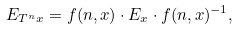Convert formula to latex. <formula><loc_0><loc_0><loc_500><loc_500>E _ { T ^ { n } x } = f ( n , x ) \cdot E _ { x } \cdot f ( n , x ) ^ { - 1 } ,</formula> 